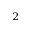Convert formula to latex. <formula><loc_0><loc_0><loc_500><loc_500>^ { 2 }</formula> 